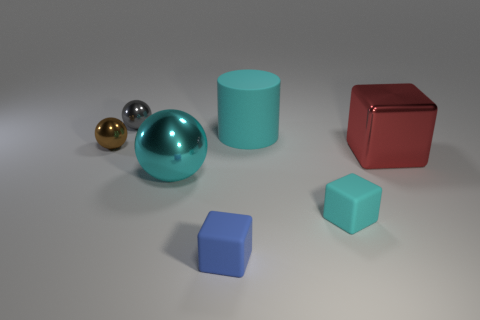Subtract 1 cubes. How many cubes are left? 2 Add 3 matte cylinders. How many objects exist? 10 Subtract all cubes. How many objects are left? 4 Subtract all tiny gray things. Subtract all gray objects. How many objects are left? 5 Add 6 cyan matte cylinders. How many cyan matte cylinders are left? 7 Add 1 brown shiny objects. How many brown shiny objects exist? 2 Subtract 0 gray cylinders. How many objects are left? 7 